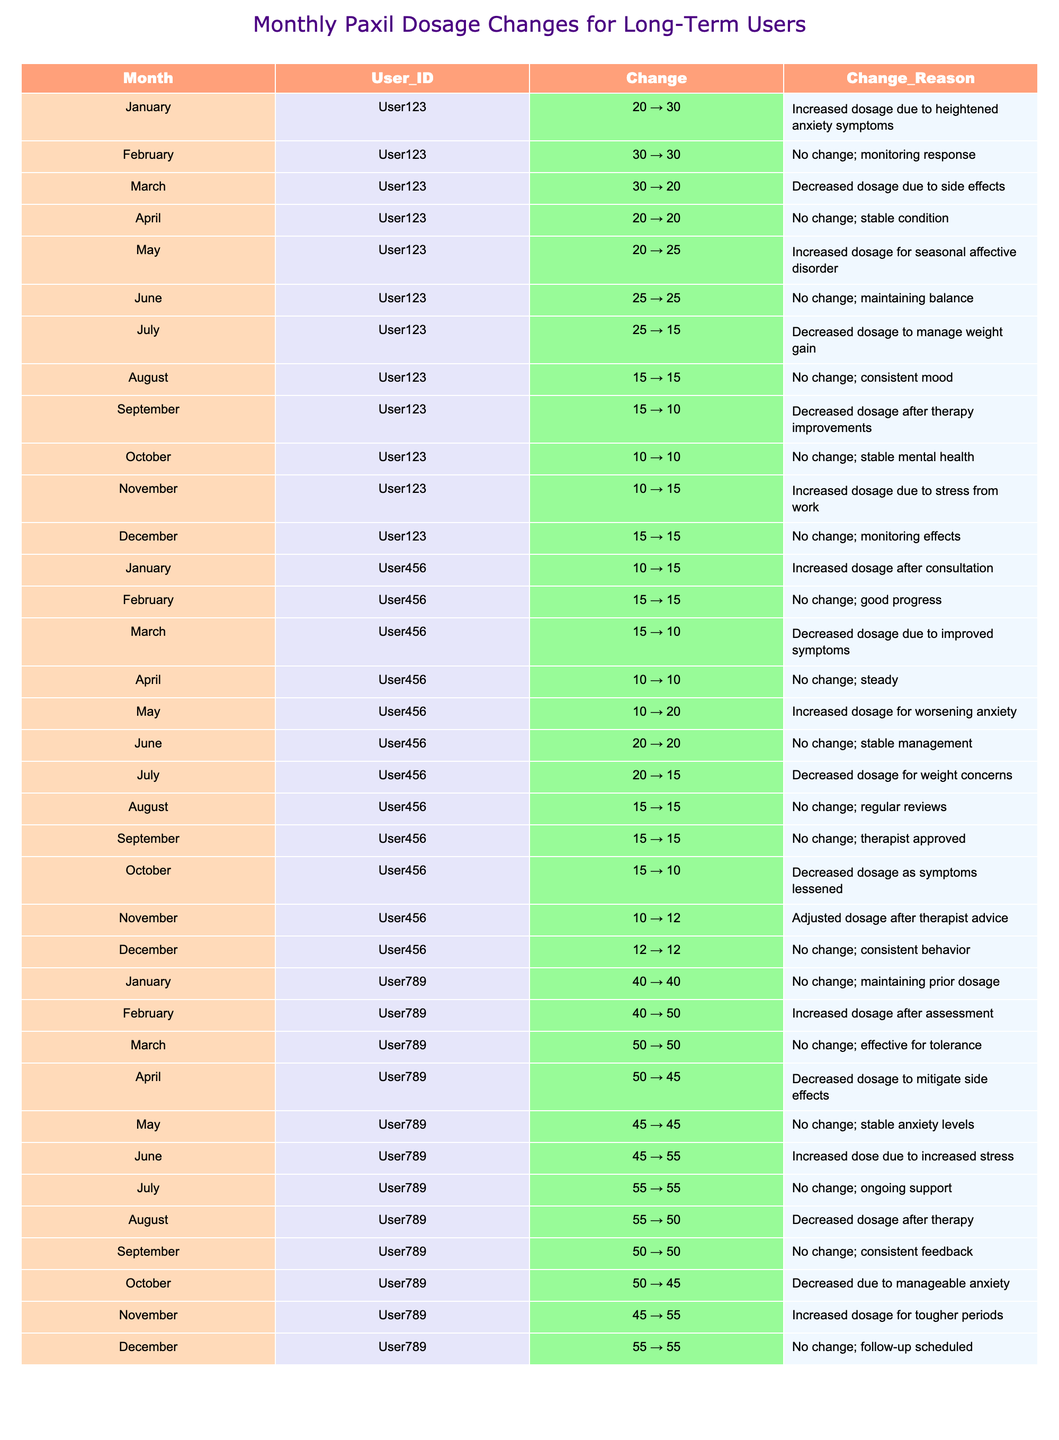What was the highest adjusted dosage recorded for User123? User123's highest adjusted dosage was 30 mg in January. I checked the "Adjusted_Dosage_mg" column for User123 and found that the highest value listed is 30 mg.
Answer: 30 mg How many times did User456's dosage increase over the year? User456's dosage increased three times: from 10 to 15 mg in January, from 10 to 20 mg in May, and from 10 to 12 mg in November. I counted the instances in the "Change" column where an increase occurred.
Answer: 3 times What was the total number of adjustments (increases and decreases) made by User789? User789 made a total of 10 adjustments throughout the year; there are 12 months with 2 instances of no change. I added up all entries that were not "No change" in the "Change_Reason" column.
Answer: 10 adjustments Did any user show a month with no change at the same dosage for two consecutive months? Yes, User123 maintained the same dosage of 15 mg for August and September. I looked for consecutive months with "No change" and the same adjusted dosage.
Answer: Yes What dosage did User456 have in June compared to May? User456's dosage was stable at 20 mg in June, increasing from 10 mg in May. I found that the adjusted dosage for May was 20 mg, and for June, it remained the same value.
Answer: 20 mg Which user had the most dosages decreased consecutively? User123 had three consecutive months of decreased dosages in July, August, and September, dropping from 25 mg to 15 mg, then to 10 mg. I traced the monthly adjustments and found this pattern for User123.
Answer: User123 What was the overall trend for User789 regarding dosage changes? User789 had an initial increase in dosage, followed by several adjustments but ultimately ended the year at the same dosage as in November (55 mg). The increases were balanced with decreases, but the final dosage stabilized. I reviewed all the monthly changes cumulatively.
Answer: Mixed adjustments with stabilization In which month did User123 have the lowest adjusted dosage? User123 had the lowest adjusted dosage of 10 mg in October. I searched for the minimum value in the "Adjusted_Dosage_mg" column for User123.
Answer: October What was the change reason for the adjustment made by User456 in November? The reason for the adjustment in November was "Adjusted dosage after therapist advice." I looked at the corresponding month for User456 and referred to the "Change_Reason" column.
Answer: Adjusted dosage after therapist advice Did any users revert to a previous dosage after an increase? Yes, User789 reverted from an increased dosage of 55 mg back to 50 mg between August and September. I traced dosage changes and found this decrease.
Answer: Yes How many months did User123 stay at a stable dosage? User123 stayed at a stable dosage for four months: February, April, June, and October. I reviewed the months where "No change" was indicated in the "Change_Reason" column.
Answer: 4 months 